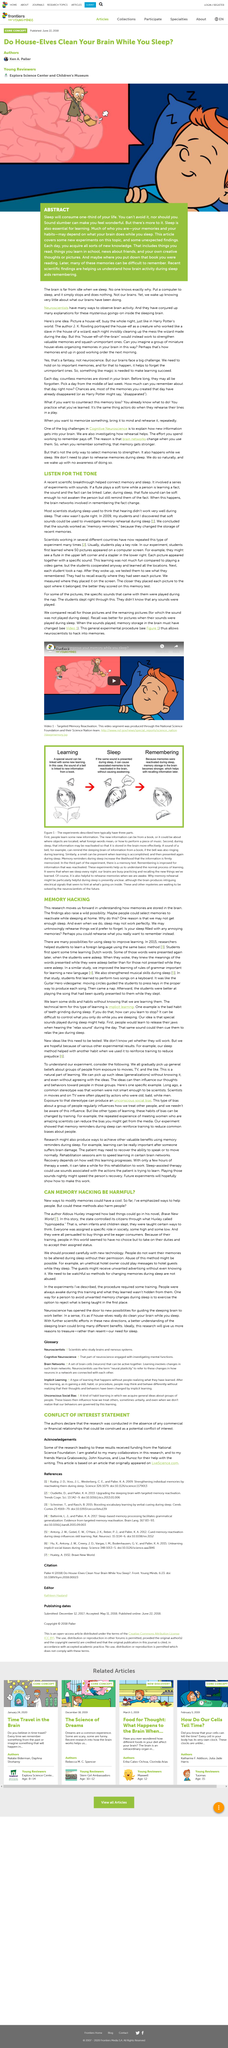Outline some significant characteristics in this image. In Huxley's novel, the state controlled its citizens through the use of Hypnopedia, a system that used hypnosis to implant messages into the minds of citizens as they slept, effectively manipulating their thoughts and actions. If your sleep is filled with annoying memories, you could rehearse what you really want to remember instead. Selecting and reactivating memories is referred to as memory hacking. The learned fact was linked to a soft tone during the experiment. It is essential for learning that what is asleep. 